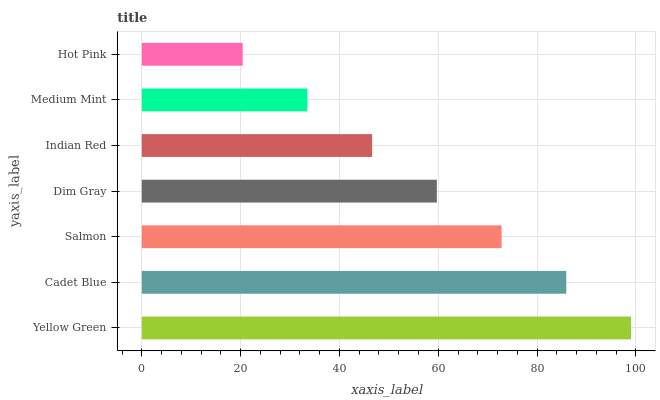Is Hot Pink the minimum?
Answer yes or no. Yes. Is Yellow Green the maximum?
Answer yes or no. Yes. Is Cadet Blue the minimum?
Answer yes or no. No. Is Cadet Blue the maximum?
Answer yes or no. No. Is Yellow Green greater than Cadet Blue?
Answer yes or no. Yes. Is Cadet Blue less than Yellow Green?
Answer yes or no. Yes. Is Cadet Blue greater than Yellow Green?
Answer yes or no. No. Is Yellow Green less than Cadet Blue?
Answer yes or no. No. Is Dim Gray the high median?
Answer yes or no. Yes. Is Dim Gray the low median?
Answer yes or no. Yes. Is Cadet Blue the high median?
Answer yes or no. No. Is Medium Mint the low median?
Answer yes or no. No. 